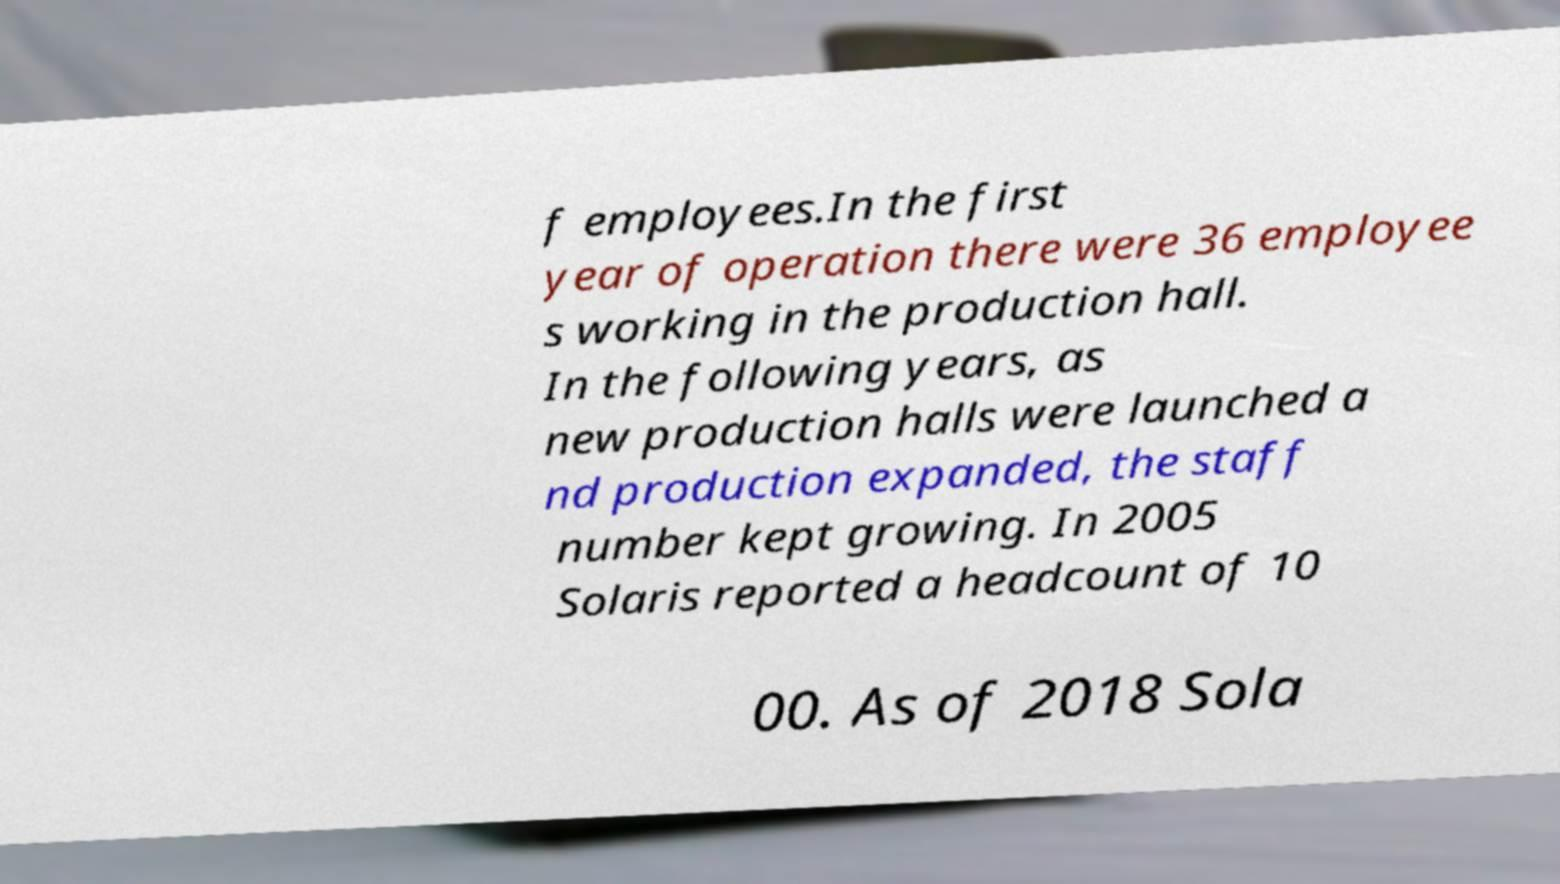Could you extract and type out the text from this image? f employees.In the first year of operation there were 36 employee s working in the production hall. In the following years, as new production halls were launched a nd production expanded, the staff number kept growing. In 2005 Solaris reported a headcount of 10 00. As of 2018 Sola 